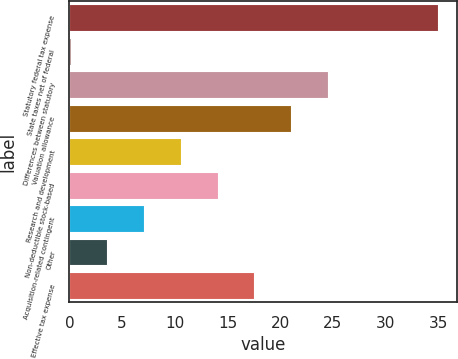Convert chart. <chart><loc_0><loc_0><loc_500><loc_500><bar_chart><fcel>Statutory federal tax expense<fcel>State taxes net of federal<fcel>Differences between statutory<fcel>Valuation allowance<fcel>Research and development<fcel>Non-deductible stock-based<fcel>Acquisition-related contingent<fcel>Other<fcel>Effective tax expense<nl><fcel>35<fcel>0.1<fcel>24.53<fcel>21.04<fcel>10.57<fcel>14.06<fcel>7.08<fcel>3.59<fcel>17.55<nl></chart> 